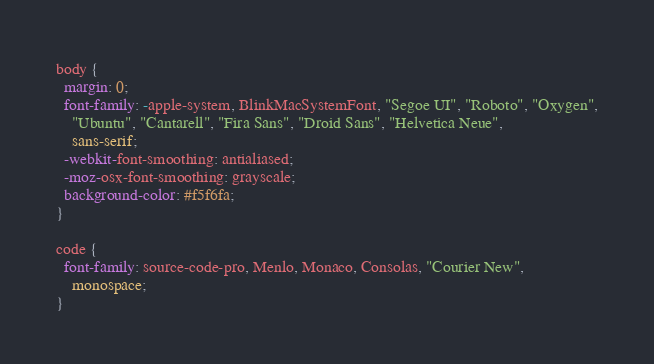<code> <loc_0><loc_0><loc_500><loc_500><_CSS_>body {
  margin: 0;
  font-family: -apple-system, BlinkMacSystemFont, "Segoe UI", "Roboto", "Oxygen",
    "Ubuntu", "Cantarell", "Fira Sans", "Droid Sans", "Helvetica Neue",
    sans-serif;
  -webkit-font-smoothing: antialiased;
  -moz-osx-font-smoothing: grayscale;
  background-color: #f5f6fa;
}

code {
  font-family: source-code-pro, Menlo, Monaco, Consolas, "Courier New",
    monospace;
}
</code> 